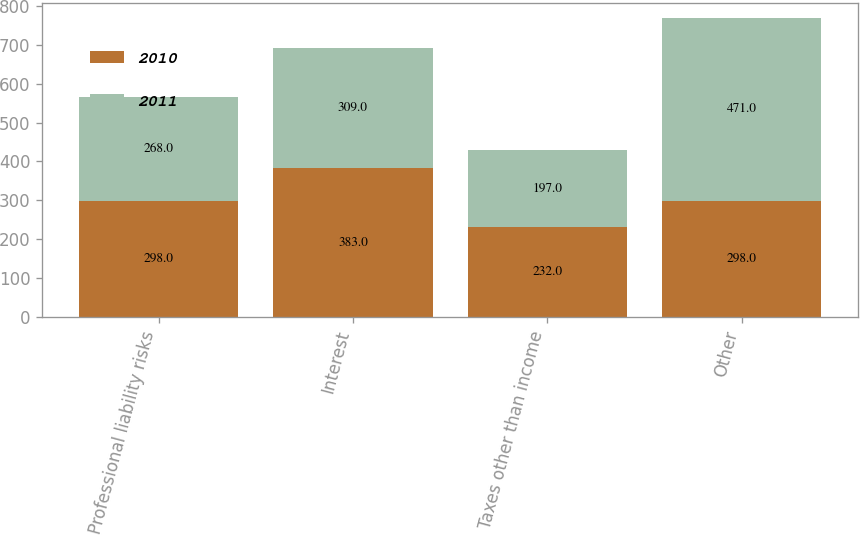Convert chart. <chart><loc_0><loc_0><loc_500><loc_500><stacked_bar_chart><ecel><fcel>Professional liability risks<fcel>Interest<fcel>Taxes other than income<fcel>Other<nl><fcel>2010<fcel>298<fcel>383<fcel>232<fcel>298<nl><fcel>2011<fcel>268<fcel>309<fcel>197<fcel>471<nl></chart> 